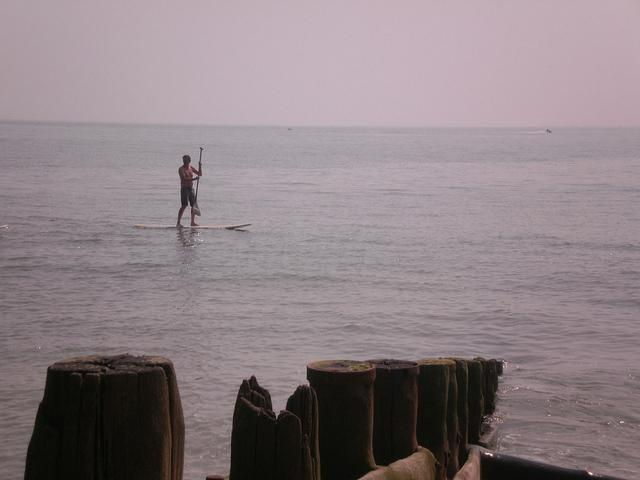Where else would his hand held tool be somewhat suitable?

Choices:
A) dining room
B) kitchen
C) math class
D) boat boat 